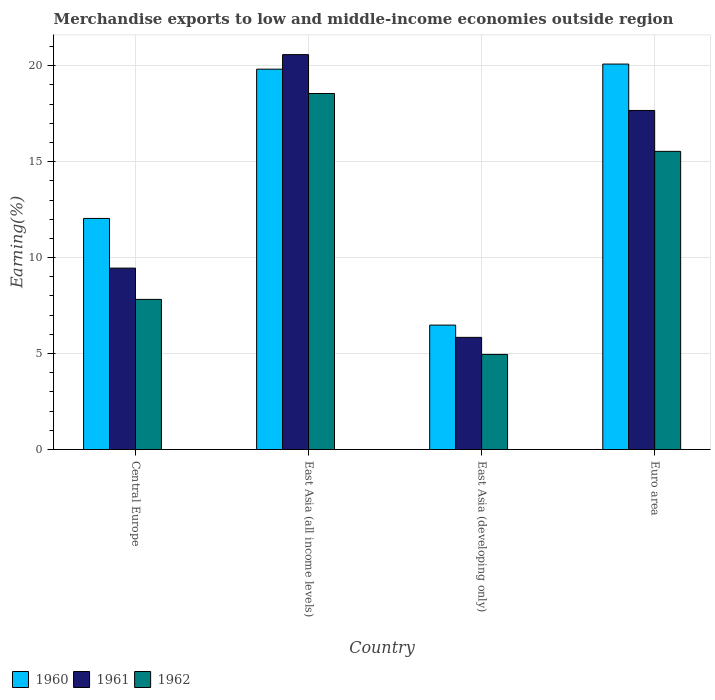How many groups of bars are there?
Your response must be concise. 4. Are the number of bars per tick equal to the number of legend labels?
Provide a succinct answer. Yes. Are the number of bars on each tick of the X-axis equal?
Your answer should be very brief. Yes. How many bars are there on the 1st tick from the right?
Your answer should be very brief. 3. In how many cases, is the number of bars for a given country not equal to the number of legend labels?
Offer a terse response. 0. What is the percentage of amount earned from merchandise exports in 1961 in Central Europe?
Offer a very short reply. 9.45. Across all countries, what is the maximum percentage of amount earned from merchandise exports in 1960?
Provide a short and direct response. 20.08. Across all countries, what is the minimum percentage of amount earned from merchandise exports in 1962?
Give a very brief answer. 4.96. In which country was the percentage of amount earned from merchandise exports in 1962 maximum?
Keep it short and to the point. East Asia (all income levels). In which country was the percentage of amount earned from merchandise exports in 1960 minimum?
Give a very brief answer. East Asia (developing only). What is the total percentage of amount earned from merchandise exports in 1960 in the graph?
Provide a succinct answer. 58.43. What is the difference between the percentage of amount earned from merchandise exports in 1962 in Central Europe and that in East Asia (developing only)?
Offer a very short reply. 2.87. What is the difference between the percentage of amount earned from merchandise exports in 1961 in Euro area and the percentage of amount earned from merchandise exports in 1962 in East Asia (developing only)?
Provide a short and direct response. 12.71. What is the average percentage of amount earned from merchandise exports in 1962 per country?
Your answer should be compact. 11.72. What is the difference between the percentage of amount earned from merchandise exports of/in 1961 and percentage of amount earned from merchandise exports of/in 1960 in East Asia (developing only)?
Offer a terse response. -0.64. What is the ratio of the percentage of amount earned from merchandise exports in 1961 in East Asia (all income levels) to that in Euro area?
Offer a very short reply. 1.16. What is the difference between the highest and the second highest percentage of amount earned from merchandise exports in 1962?
Keep it short and to the point. 10.73. What is the difference between the highest and the lowest percentage of amount earned from merchandise exports in 1961?
Provide a short and direct response. 14.73. Is the sum of the percentage of amount earned from merchandise exports in 1962 in Central Europe and Euro area greater than the maximum percentage of amount earned from merchandise exports in 1960 across all countries?
Provide a succinct answer. Yes. What does the 2nd bar from the left in Euro area represents?
Your answer should be very brief. 1961. What does the 2nd bar from the right in Central Europe represents?
Your answer should be very brief. 1961. How many bars are there?
Offer a terse response. 12. How many countries are there in the graph?
Give a very brief answer. 4. What is the difference between two consecutive major ticks on the Y-axis?
Your answer should be very brief. 5. Are the values on the major ticks of Y-axis written in scientific E-notation?
Provide a succinct answer. No. What is the title of the graph?
Your response must be concise. Merchandise exports to low and middle-income economies outside region. Does "2001" appear as one of the legend labels in the graph?
Your response must be concise. No. What is the label or title of the X-axis?
Ensure brevity in your answer.  Country. What is the label or title of the Y-axis?
Offer a very short reply. Earning(%). What is the Earning(%) of 1960 in Central Europe?
Provide a short and direct response. 12.04. What is the Earning(%) of 1961 in Central Europe?
Ensure brevity in your answer.  9.45. What is the Earning(%) of 1962 in Central Europe?
Offer a terse response. 7.82. What is the Earning(%) in 1960 in East Asia (all income levels)?
Your response must be concise. 19.82. What is the Earning(%) of 1961 in East Asia (all income levels)?
Provide a succinct answer. 20.58. What is the Earning(%) of 1962 in East Asia (all income levels)?
Offer a very short reply. 18.55. What is the Earning(%) of 1960 in East Asia (developing only)?
Make the answer very short. 6.48. What is the Earning(%) in 1961 in East Asia (developing only)?
Offer a terse response. 5.84. What is the Earning(%) of 1962 in East Asia (developing only)?
Provide a succinct answer. 4.96. What is the Earning(%) of 1960 in Euro area?
Provide a short and direct response. 20.08. What is the Earning(%) of 1961 in Euro area?
Offer a terse response. 17.67. What is the Earning(%) in 1962 in Euro area?
Your answer should be very brief. 15.54. Across all countries, what is the maximum Earning(%) in 1960?
Offer a very short reply. 20.08. Across all countries, what is the maximum Earning(%) in 1961?
Your answer should be compact. 20.58. Across all countries, what is the maximum Earning(%) of 1962?
Make the answer very short. 18.55. Across all countries, what is the minimum Earning(%) of 1960?
Make the answer very short. 6.48. Across all countries, what is the minimum Earning(%) of 1961?
Make the answer very short. 5.84. Across all countries, what is the minimum Earning(%) in 1962?
Offer a very short reply. 4.96. What is the total Earning(%) of 1960 in the graph?
Ensure brevity in your answer.  58.43. What is the total Earning(%) of 1961 in the graph?
Provide a succinct answer. 53.54. What is the total Earning(%) in 1962 in the graph?
Make the answer very short. 46.87. What is the difference between the Earning(%) in 1960 in Central Europe and that in East Asia (all income levels)?
Your answer should be very brief. -7.78. What is the difference between the Earning(%) in 1961 in Central Europe and that in East Asia (all income levels)?
Offer a very short reply. -11.12. What is the difference between the Earning(%) of 1962 in Central Europe and that in East Asia (all income levels)?
Provide a short and direct response. -10.73. What is the difference between the Earning(%) of 1960 in Central Europe and that in East Asia (developing only)?
Offer a terse response. 5.56. What is the difference between the Earning(%) of 1961 in Central Europe and that in East Asia (developing only)?
Provide a short and direct response. 3.61. What is the difference between the Earning(%) of 1962 in Central Europe and that in East Asia (developing only)?
Your answer should be compact. 2.87. What is the difference between the Earning(%) of 1960 in Central Europe and that in Euro area?
Offer a very short reply. -8.04. What is the difference between the Earning(%) in 1961 in Central Europe and that in Euro area?
Make the answer very short. -8.21. What is the difference between the Earning(%) of 1962 in Central Europe and that in Euro area?
Offer a terse response. -7.71. What is the difference between the Earning(%) in 1960 in East Asia (all income levels) and that in East Asia (developing only)?
Make the answer very short. 13.33. What is the difference between the Earning(%) in 1961 in East Asia (all income levels) and that in East Asia (developing only)?
Provide a succinct answer. 14.73. What is the difference between the Earning(%) of 1962 in East Asia (all income levels) and that in East Asia (developing only)?
Provide a succinct answer. 13.6. What is the difference between the Earning(%) in 1960 in East Asia (all income levels) and that in Euro area?
Ensure brevity in your answer.  -0.27. What is the difference between the Earning(%) of 1961 in East Asia (all income levels) and that in Euro area?
Provide a short and direct response. 2.91. What is the difference between the Earning(%) of 1962 in East Asia (all income levels) and that in Euro area?
Your answer should be compact. 3.02. What is the difference between the Earning(%) in 1960 in East Asia (developing only) and that in Euro area?
Make the answer very short. -13.6. What is the difference between the Earning(%) in 1961 in East Asia (developing only) and that in Euro area?
Offer a very short reply. -11.82. What is the difference between the Earning(%) in 1962 in East Asia (developing only) and that in Euro area?
Give a very brief answer. -10.58. What is the difference between the Earning(%) in 1960 in Central Europe and the Earning(%) in 1961 in East Asia (all income levels)?
Ensure brevity in your answer.  -8.54. What is the difference between the Earning(%) of 1960 in Central Europe and the Earning(%) of 1962 in East Asia (all income levels)?
Make the answer very short. -6.51. What is the difference between the Earning(%) in 1961 in Central Europe and the Earning(%) in 1962 in East Asia (all income levels)?
Your response must be concise. -9.1. What is the difference between the Earning(%) in 1960 in Central Europe and the Earning(%) in 1961 in East Asia (developing only)?
Provide a succinct answer. 6.2. What is the difference between the Earning(%) of 1960 in Central Europe and the Earning(%) of 1962 in East Asia (developing only)?
Give a very brief answer. 7.09. What is the difference between the Earning(%) of 1961 in Central Europe and the Earning(%) of 1962 in East Asia (developing only)?
Your answer should be very brief. 4.5. What is the difference between the Earning(%) in 1960 in Central Europe and the Earning(%) in 1961 in Euro area?
Give a very brief answer. -5.63. What is the difference between the Earning(%) of 1960 in Central Europe and the Earning(%) of 1962 in Euro area?
Give a very brief answer. -3.49. What is the difference between the Earning(%) in 1961 in Central Europe and the Earning(%) in 1962 in Euro area?
Offer a terse response. -6.08. What is the difference between the Earning(%) in 1960 in East Asia (all income levels) and the Earning(%) in 1961 in East Asia (developing only)?
Ensure brevity in your answer.  13.97. What is the difference between the Earning(%) of 1960 in East Asia (all income levels) and the Earning(%) of 1962 in East Asia (developing only)?
Your answer should be compact. 14.86. What is the difference between the Earning(%) of 1961 in East Asia (all income levels) and the Earning(%) of 1962 in East Asia (developing only)?
Give a very brief answer. 15.62. What is the difference between the Earning(%) of 1960 in East Asia (all income levels) and the Earning(%) of 1961 in Euro area?
Ensure brevity in your answer.  2.15. What is the difference between the Earning(%) in 1960 in East Asia (all income levels) and the Earning(%) in 1962 in Euro area?
Your response must be concise. 4.28. What is the difference between the Earning(%) in 1961 in East Asia (all income levels) and the Earning(%) in 1962 in Euro area?
Ensure brevity in your answer.  5.04. What is the difference between the Earning(%) of 1960 in East Asia (developing only) and the Earning(%) of 1961 in Euro area?
Your response must be concise. -11.18. What is the difference between the Earning(%) of 1960 in East Asia (developing only) and the Earning(%) of 1962 in Euro area?
Offer a very short reply. -9.05. What is the difference between the Earning(%) in 1961 in East Asia (developing only) and the Earning(%) in 1962 in Euro area?
Ensure brevity in your answer.  -9.69. What is the average Earning(%) of 1960 per country?
Your answer should be very brief. 14.61. What is the average Earning(%) in 1961 per country?
Give a very brief answer. 13.39. What is the average Earning(%) of 1962 per country?
Your answer should be very brief. 11.72. What is the difference between the Earning(%) in 1960 and Earning(%) in 1961 in Central Europe?
Provide a succinct answer. 2.59. What is the difference between the Earning(%) of 1960 and Earning(%) of 1962 in Central Europe?
Give a very brief answer. 4.22. What is the difference between the Earning(%) of 1961 and Earning(%) of 1962 in Central Europe?
Offer a terse response. 1.63. What is the difference between the Earning(%) of 1960 and Earning(%) of 1961 in East Asia (all income levels)?
Provide a succinct answer. -0.76. What is the difference between the Earning(%) of 1960 and Earning(%) of 1962 in East Asia (all income levels)?
Offer a very short reply. 1.27. What is the difference between the Earning(%) in 1961 and Earning(%) in 1962 in East Asia (all income levels)?
Ensure brevity in your answer.  2.03. What is the difference between the Earning(%) in 1960 and Earning(%) in 1961 in East Asia (developing only)?
Your answer should be compact. 0.64. What is the difference between the Earning(%) in 1960 and Earning(%) in 1962 in East Asia (developing only)?
Ensure brevity in your answer.  1.53. What is the difference between the Earning(%) in 1961 and Earning(%) in 1962 in East Asia (developing only)?
Make the answer very short. 0.89. What is the difference between the Earning(%) in 1960 and Earning(%) in 1961 in Euro area?
Make the answer very short. 2.42. What is the difference between the Earning(%) of 1960 and Earning(%) of 1962 in Euro area?
Your response must be concise. 4.55. What is the difference between the Earning(%) of 1961 and Earning(%) of 1962 in Euro area?
Ensure brevity in your answer.  2.13. What is the ratio of the Earning(%) of 1960 in Central Europe to that in East Asia (all income levels)?
Your answer should be very brief. 0.61. What is the ratio of the Earning(%) of 1961 in Central Europe to that in East Asia (all income levels)?
Your response must be concise. 0.46. What is the ratio of the Earning(%) in 1962 in Central Europe to that in East Asia (all income levels)?
Your response must be concise. 0.42. What is the ratio of the Earning(%) of 1960 in Central Europe to that in East Asia (developing only)?
Your answer should be very brief. 1.86. What is the ratio of the Earning(%) in 1961 in Central Europe to that in East Asia (developing only)?
Offer a terse response. 1.62. What is the ratio of the Earning(%) in 1962 in Central Europe to that in East Asia (developing only)?
Give a very brief answer. 1.58. What is the ratio of the Earning(%) of 1960 in Central Europe to that in Euro area?
Give a very brief answer. 0.6. What is the ratio of the Earning(%) of 1961 in Central Europe to that in Euro area?
Provide a short and direct response. 0.54. What is the ratio of the Earning(%) of 1962 in Central Europe to that in Euro area?
Your answer should be very brief. 0.5. What is the ratio of the Earning(%) of 1960 in East Asia (all income levels) to that in East Asia (developing only)?
Make the answer very short. 3.06. What is the ratio of the Earning(%) in 1961 in East Asia (all income levels) to that in East Asia (developing only)?
Provide a short and direct response. 3.52. What is the ratio of the Earning(%) in 1962 in East Asia (all income levels) to that in East Asia (developing only)?
Ensure brevity in your answer.  3.74. What is the ratio of the Earning(%) of 1960 in East Asia (all income levels) to that in Euro area?
Your response must be concise. 0.99. What is the ratio of the Earning(%) of 1961 in East Asia (all income levels) to that in Euro area?
Your response must be concise. 1.16. What is the ratio of the Earning(%) of 1962 in East Asia (all income levels) to that in Euro area?
Offer a very short reply. 1.19. What is the ratio of the Earning(%) in 1960 in East Asia (developing only) to that in Euro area?
Your answer should be very brief. 0.32. What is the ratio of the Earning(%) of 1961 in East Asia (developing only) to that in Euro area?
Make the answer very short. 0.33. What is the ratio of the Earning(%) in 1962 in East Asia (developing only) to that in Euro area?
Make the answer very short. 0.32. What is the difference between the highest and the second highest Earning(%) in 1960?
Your answer should be very brief. 0.27. What is the difference between the highest and the second highest Earning(%) in 1961?
Give a very brief answer. 2.91. What is the difference between the highest and the second highest Earning(%) in 1962?
Your answer should be very brief. 3.02. What is the difference between the highest and the lowest Earning(%) in 1960?
Your answer should be very brief. 13.6. What is the difference between the highest and the lowest Earning(%) in 1961?
Your answer should be very brief. 14.73. What is the difference between the highest and the lowest Earning(%) in 1962?
Your response must be concise. 13.6. 